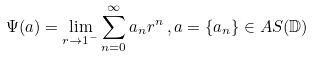<formula> <loc_0><loc_0><loc_500><loc_500>\Psi ( a ) = \lim _ { r \rightarrow 1 ^ { - } } \sum _ { n = 0 } ^ { \infty } a _ { n } r ^ { n } \, , a = \{ a _ { n } \} \in A S ( \mathbb { D } )</formula> 